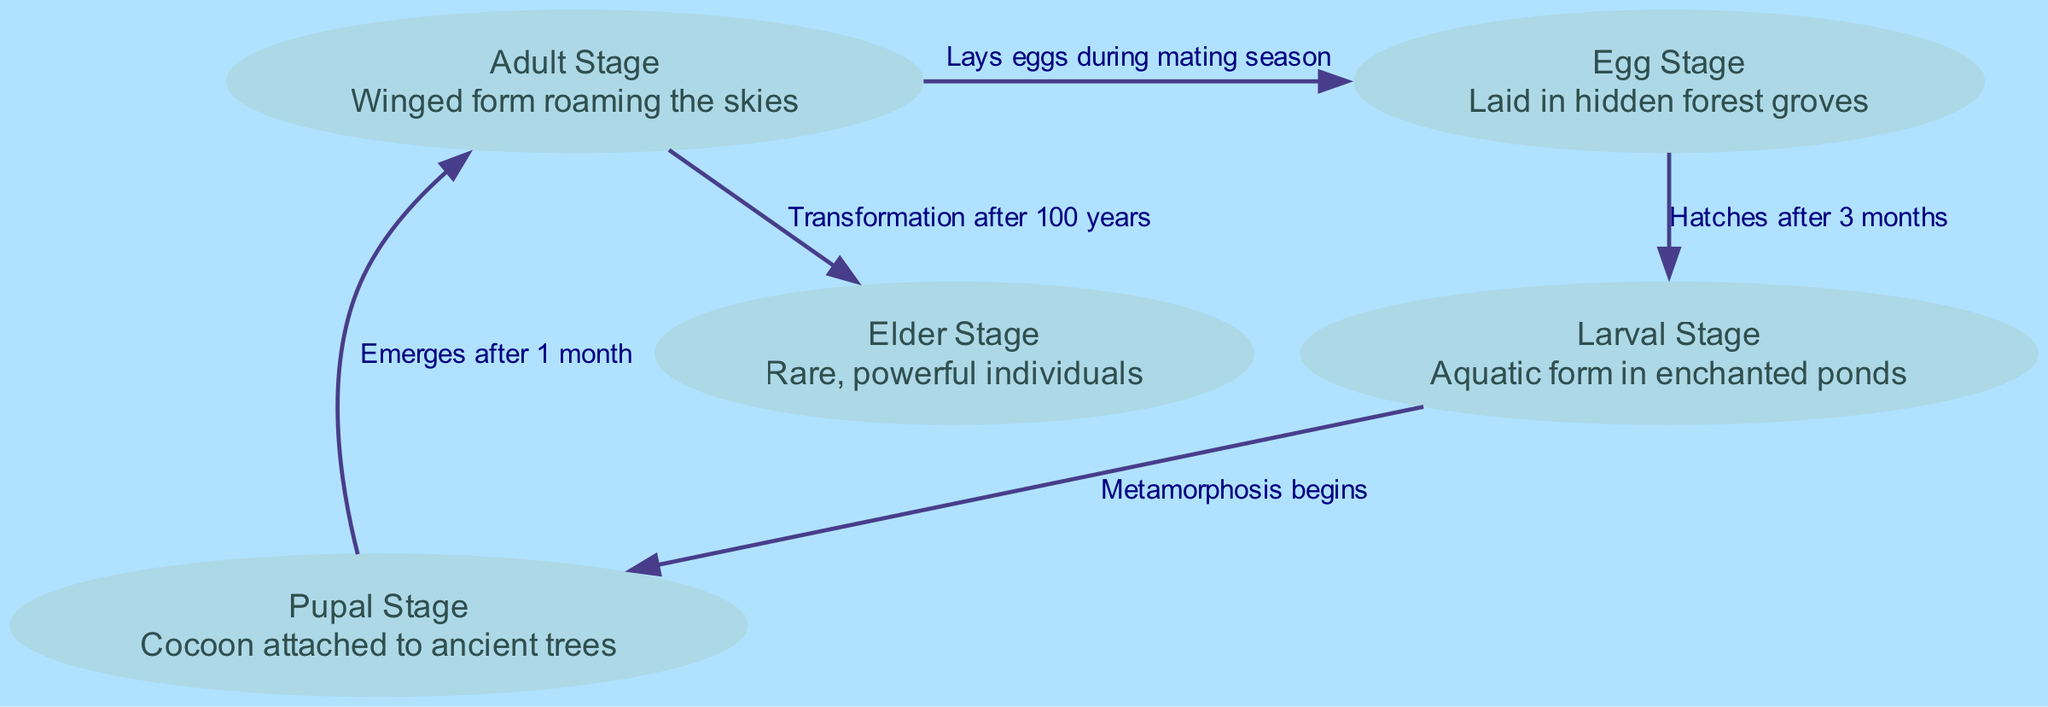What is the first stage of the life cycle? The diagram indicates that the first stage is represented by the node labeled "Egg Stage." This is identifiable as it is the starting node in the flow of the life cycle.
Answer: Egg Stage How long does the egg take to hatch? The edge connecting "egg" to "larva" specifies the relationship that it hatches after 3 months. This piece of information is found directly on the edge label.
Answer: 3 months What is the last stage before becoming an elder? The node labeled "Adult Stage" is the last stage before the transition to the elder stage. This can be confirmed by the direct flow from the adult node to the elder node.
Answer: Adult Stage How many total stages are in the life cycle? Counting the nodes listed in the diagram, there are five distinct stages: egg, larva, pupa, adult, and elder. Thus, the total number of stages is five.
Answer: 5 What transformation occurs after 100 years? The edge connects the "Adult Stage" to the "Elder Stage" with the label indicating a transformation occurs after 100 years. This indicates a significant marker in the life cycle flow.
Answer: Transformation after 100 years Which stage is aquatic? The "Larval Stage" is described as the aquatic form in enchanted ponds. This can be confirmed by reading the description of that specific node.
Answer: Larval Stage What does the adult stage do during mating season? According to the diagram, the edge from "adult" to "egg" states that the adult lays eggs during the mating season, indicating a reproductive action within this life stage.
Answer: Lays eggs during mating season What stage follows metamorphosis? The "Pupal Stage" transitions to the "Adult Stage" and is described as the stage where metamorphosis begins. This establishes the sequence of stages clearly in the diagram.
Answer: Adult Stage What attachment point does the pupal stage have? The "Pupal Stage" is described as being a cocoon that is attached to ancient trees. This is directly stated in the description segment of the corresponding node.
Answer: Attached to ancient trees 